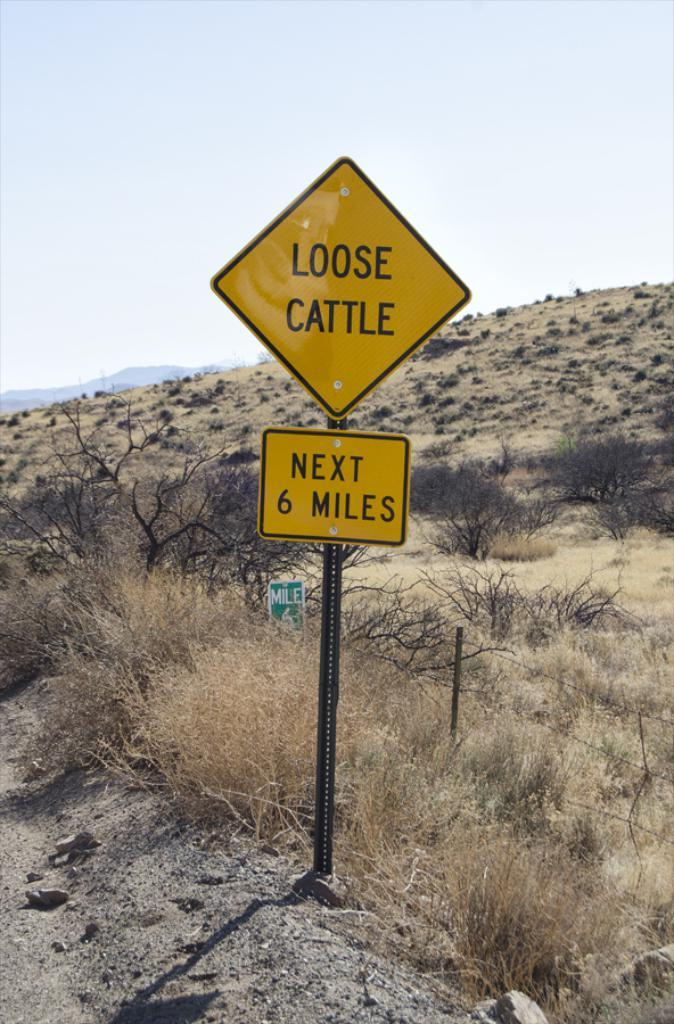<image>
Describe the image concisely. A yellow sign that says Loose Cattle Next 6 Miles/ 